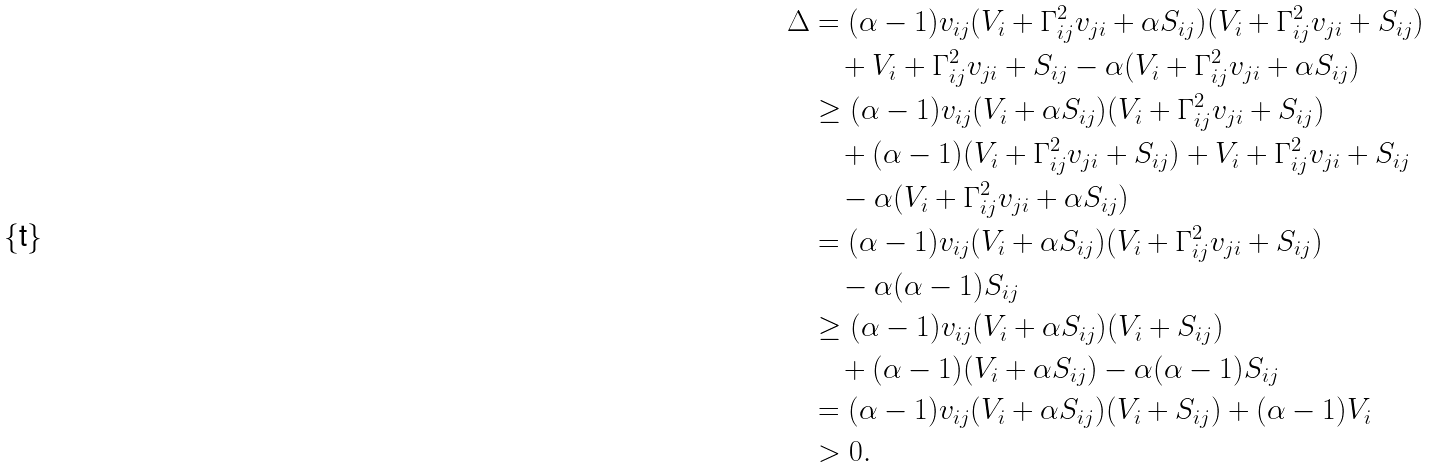Convert formula to latex. <formula><loc_0><loc_0><loc_500><loc_500>\Delta & = ( \alpha - 1 ) v _ { i j } ( V _ { i } + \Gamma _ { i j } ^ { 2 } v _ { j i } + \alpha S _ { i j } ) ( V _ { i } + \Gamma _ { i j } ^ { 2 } v _ { j i } + S _ { i j } ) \\ & \quad + V _ { i } + \Gamma _ { i j } ^ { 2 } v _ { j i } + S _ { i j } - \alpha ( V _ { i } + \Gamma _ { i j } ^ { 2 } v _ { j i } + \alpha S _ { i j } ) \\ & \geq ( \alpha - 1 ) v _ { i j } ( V _ { i } + \alpha S _ { i j } ) ( V _ { i } + \Gamma _ { i j } ^ { 2 } v _ { j i } + S _ { i j } ) \\ & \quad + ( \alpha - 1 ) ( V _ { i } + \Gamma _ { i j } ^ { 2 } v _ { j i } + S _ { i j } ) + V _ { i } + \Gamma _ { i j } ^ { 2 } v _ { j i } + S _ { i j } \\ & \quad - \alpha ( V _ { i } + \Gamma _ { i j } ^ { 2 } v _ { j i } + \alpha S _ { i j } ) \\ & = ( \alpha - 1 ) v _ { i j } ( V _ { i } + \alpha S _ { i j } ) ( V _ { i } + \Gamma _ { i j } ^ { 2 } v _ { j i } + S _ { i j } ) \\ & \quad - \alpha ( \alpha - 1 ) S _ { i j } \\ & \geq ( \alpha - 1 ) v _ { i j } ( V _ { i } + \alpha S _ { i j } ) ( V _ { i } + S _ { i j } ) \\ & \quad + ( \alpha - 1 ) ( V _ { i } + \alpha S _ { i j } ) - \alpha ( \alpha - 1 ) S _ { i j } \\ & = ( \alpha - 1 ) v _ { i j } ( V _ { i } + \alpha S _ { i j } ) ( V _ { i } + S _ { i j } ) + ( \alpha - 1 ) V _ { i } \\ & > 0 .</formula> 